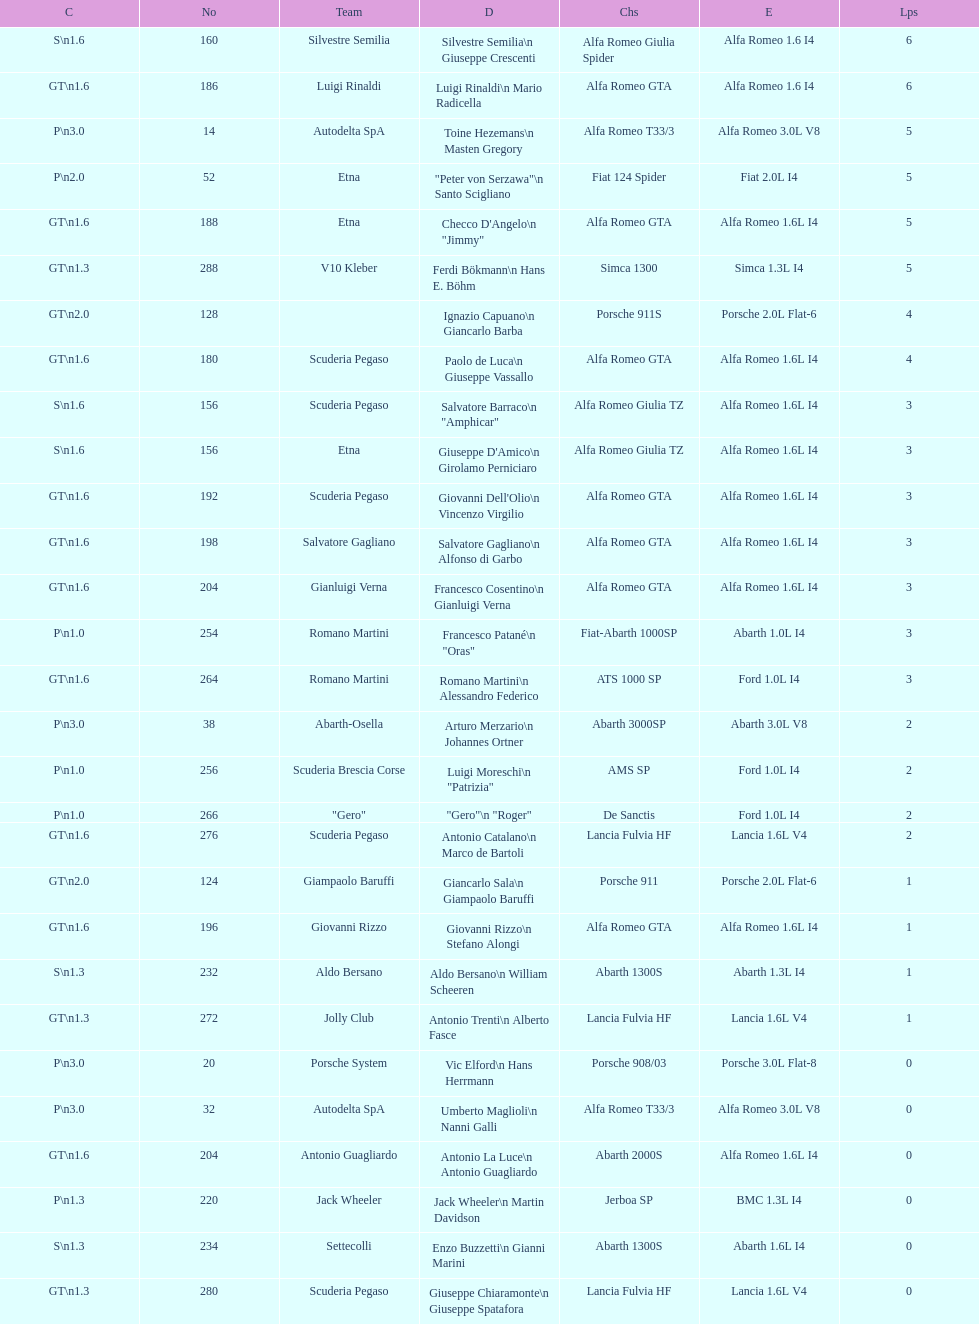Which chassis is in the middle of simca 1300 and alfa romeo gta? Porsche 911S. 